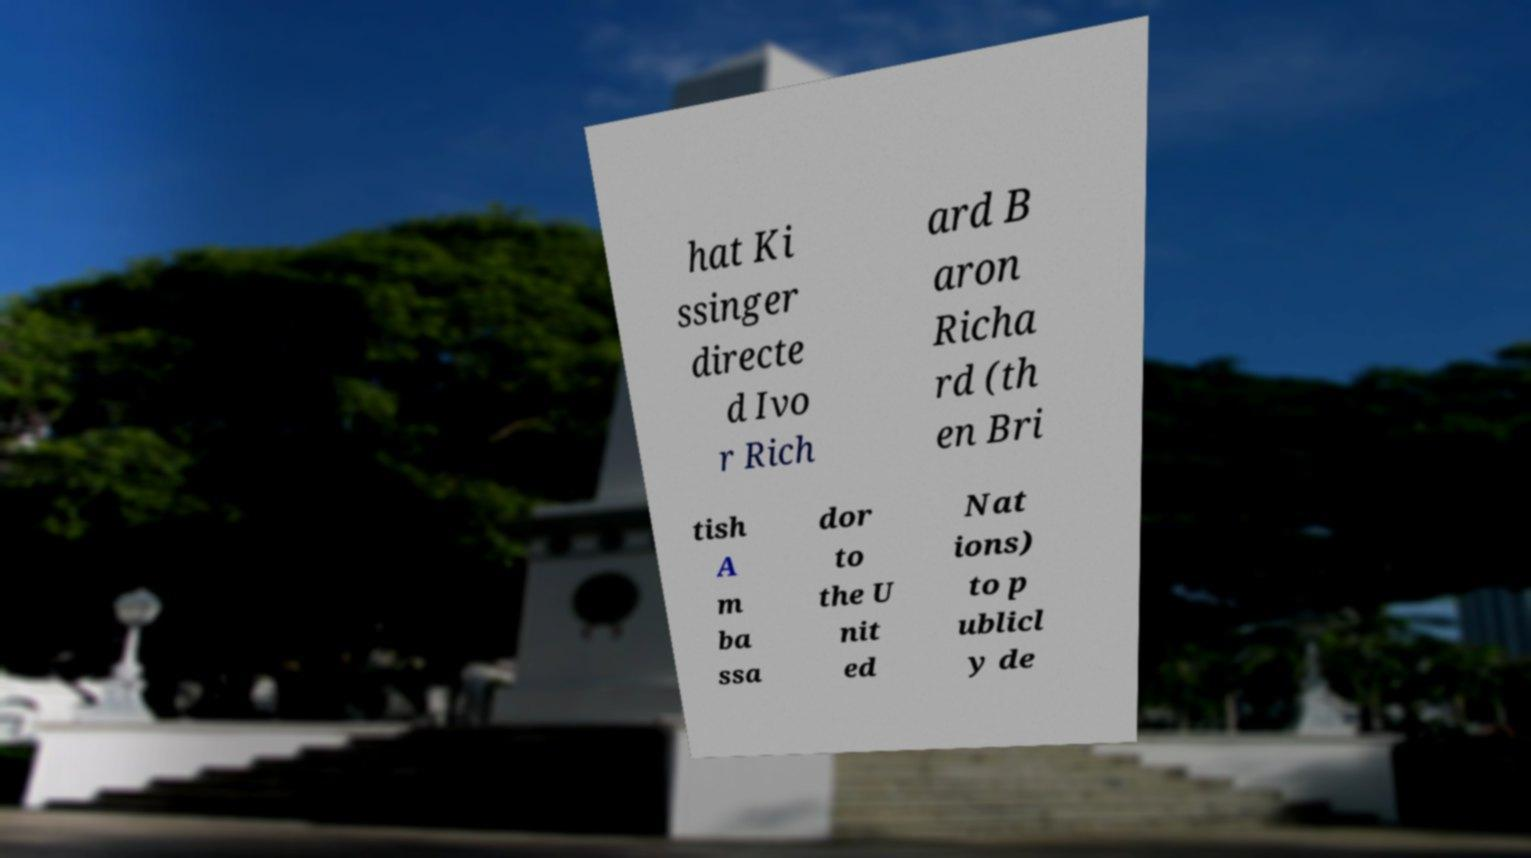Could you assist in decoding the text presented in this image and type it out clearly? hat Ki ssinger directe d Ivo r Rich ard B aron Richa rd (th en Bri tish A m ba ssa dor to the U nit ed Nat ions) to p ublicl y de 